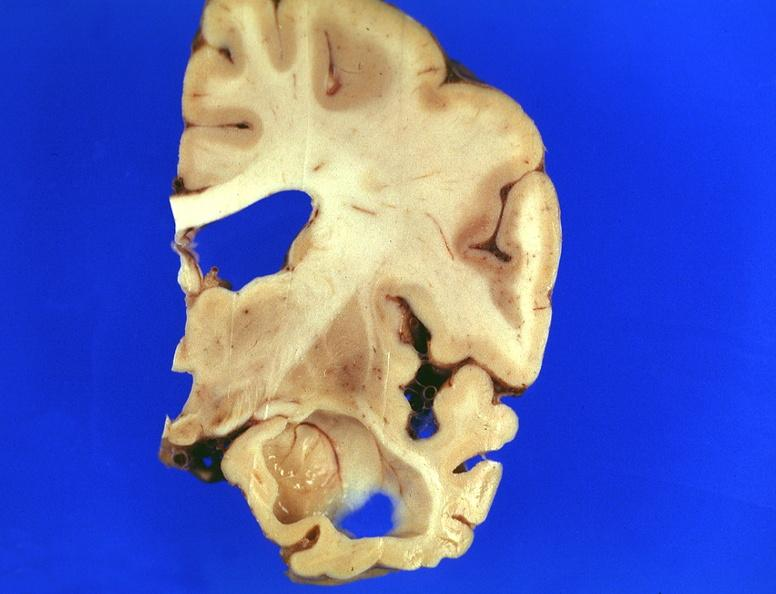s nervous present?
Answer the question using a single word or phrase. Yes 